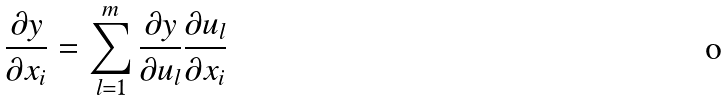Convert formula to latex. <formula><loc_0><loc_0><loc_500><loc_500>\frac { \partial y } { \partial x _ { i } } = \sum _ { l = 1 } ^ { m } \frac { \partial y } { \partial u _ { l } } \frac { \partial u _ { l } } { \partial x _ { i } }</formula> 